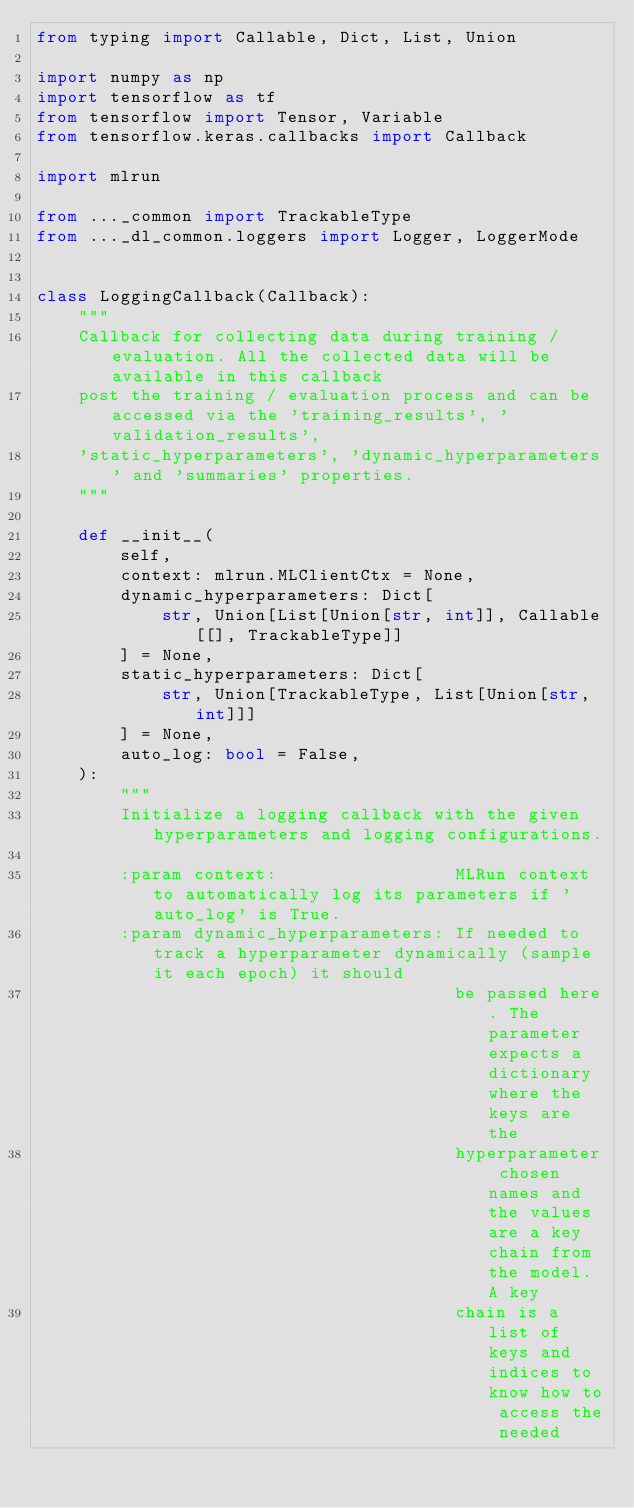Convert code to text. <code><loc_0><loc_0><loc_500><loc_500><_Python_>from typing import Callable, Dict, List, Union

import numpy as np
import tensorflow as tf
from tensorflow import Tensor, Variable
from tensorflow.keras.callbacks import Callback

import mlrun

from ..._common import TrackableType
from ..._dl_common.loggers import Logger, LoggerMode


class LoggingCallback(Callback):
    """
    Callback for collecting data during training / evaluation. All the collected data will be available in this callback
    post the training / evaluation process and can be accessed via the 'training_results', 'validation_results',
    'static_hyperparameters', 'dynamic_hyperparameters' and 'summaries' properties.
    """

    def __init__(
        self,
        context: mlrun.MLClientCtx = None,
        dynamic_hyperparameters: Dict[
            str, Union[List[Union[str, int]], Callable[[], TrackableType]]
        ] = None,
        static_hyperparameters: Dict[
            str, Union[TrackableType, List[Union[str, int]]]
        ] = None,
        auto_log: bool = False,
    ):
        """
        Initialize a logging callback with the given hyperparameters and logging configurations.

        :param context:                 MLRun context to automatically log its parameters if 'auto_log' is True.
        :param dynamic_hyperparameters: If needed to track a hyperparameter dynamically (sample it each epoch) it should
                                        be passed here. The parameter expects a dictionary where the keys are the
                                        hyperparameter chosen names and the values are a key chain from the model. A key
                                        chain is a list of keys and indices to know how to access the needed</code> 